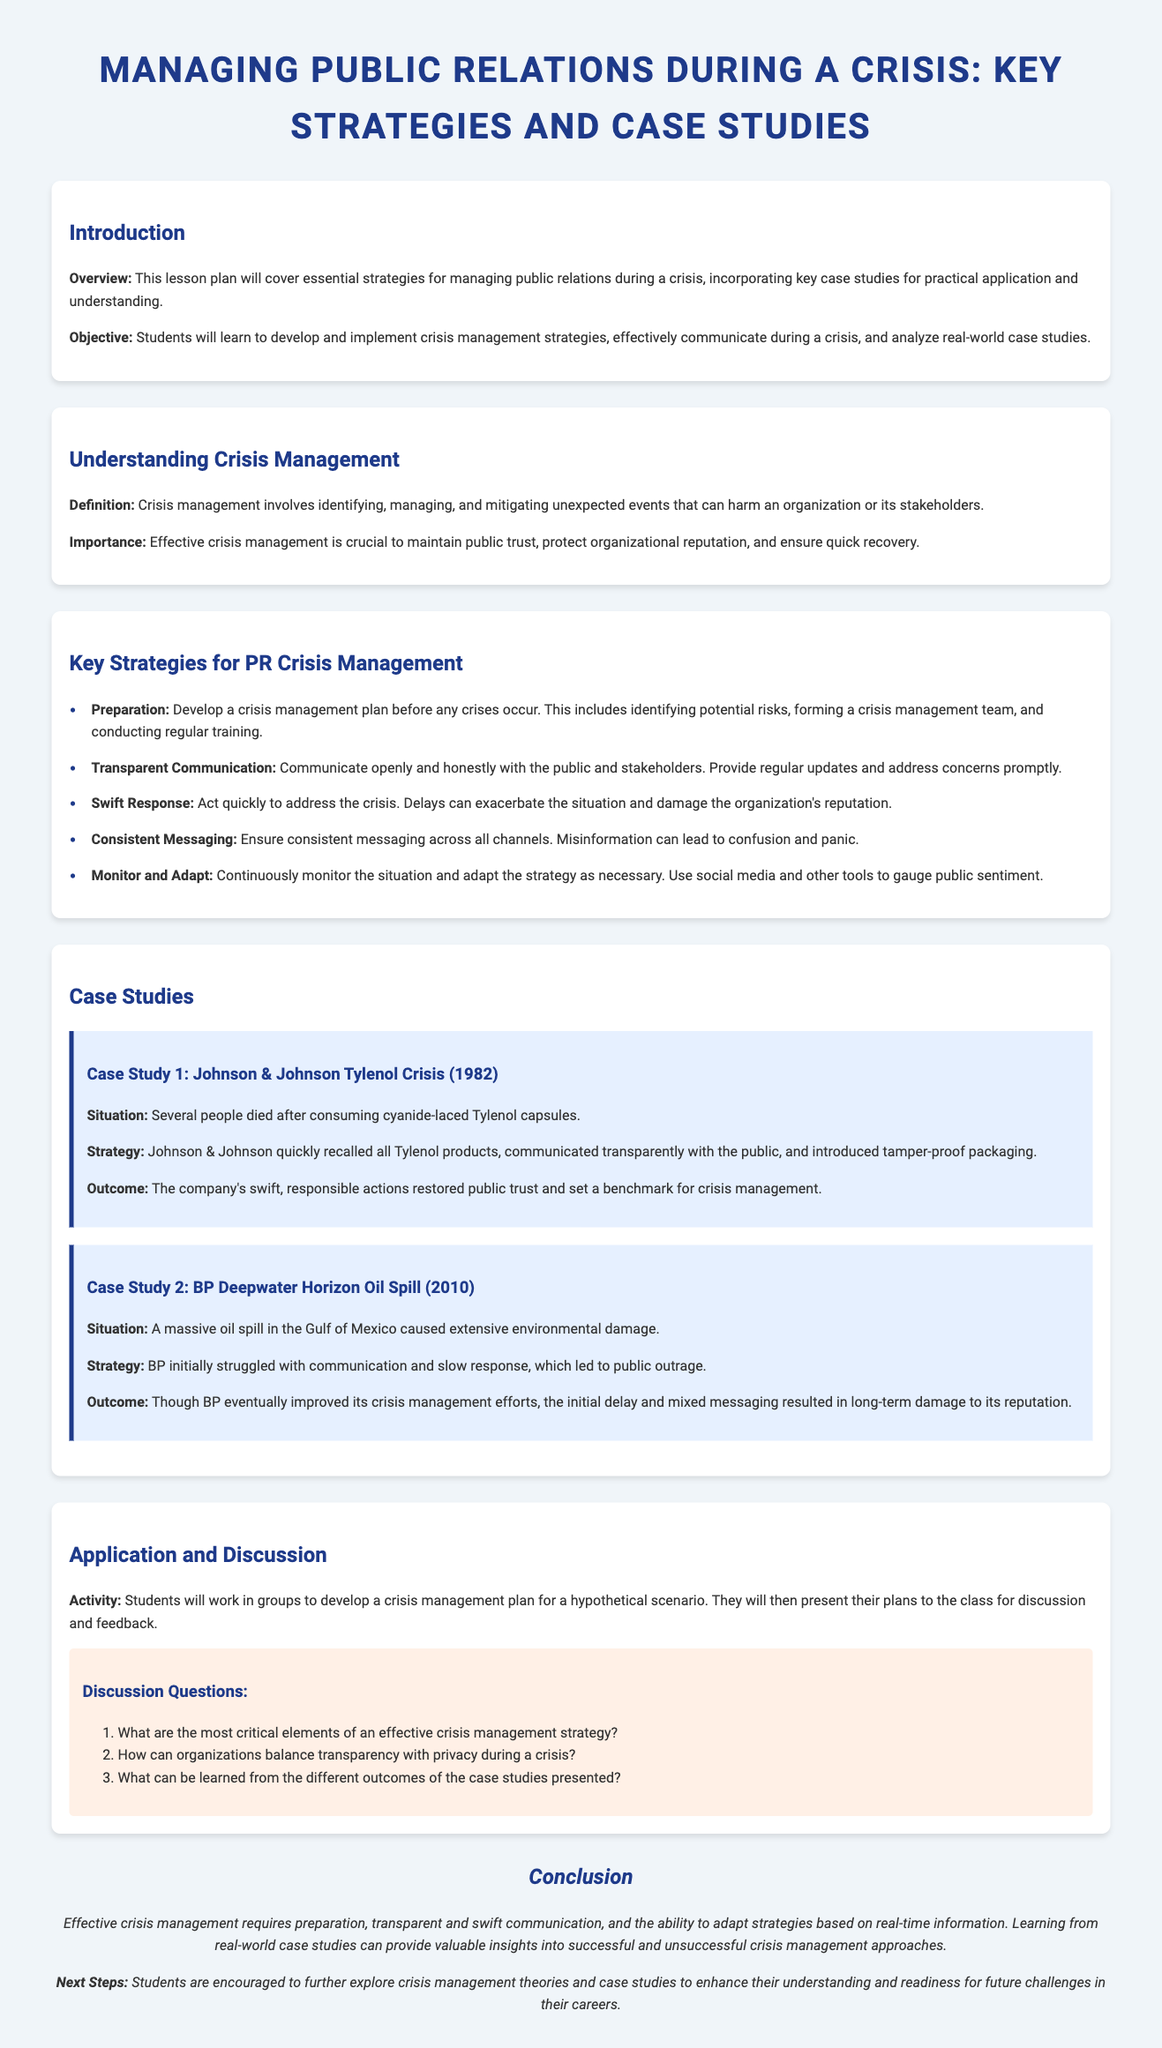What is the title of the lesson plan? The title of the lesson plan is the first element presented in the document, identifying the main topic of study.
Answer: Managing Public Relations during a Crisis: Key Strategies and Case Studies What is one key strategy for PR crisis management? The document lists several strategies; one example can be directly retrieved from the provided strategies section.
Answer: Transparent Communication What year did the Johnson & Johnson Tylenol Crisis occur? The document specifies the year of this case study in the case description.
Answer: 1982 What was the main issue in the BP Deepwater Horizon Oil Spill case study? The document outlines the issue in the situation description of the case study.
Answer: A massive oil spill What is the objective of this lesson plan? The objective is described clearly at the beginning of the document, defining what students are expected to learn.
Answer: Students will learn to develop and implement crisis management strategies How many discussion questions are presented in the document? The number of discussion questions can be counted from the section that contains them.
Answer: Three What color is used for the background of the case studies? The document specifies the color used for case studies in the design description.
Answer: Light blue What is a critical element of effective crisis management, according to the document? The document indicates critical elements under the key strategies for PR crisis management.
Answer: Preparation 